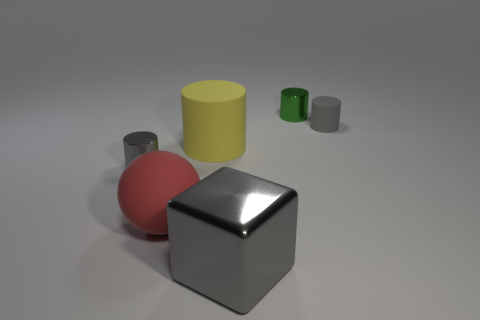Subtract all green cylinders. How many cylinders are left? 3 Subtract all gray cylinders. How many cylinders are left? 2 Subtract all blocks. How many objects are left? 5 Subtract 1 cylinders. How many cylinders are left? 3 Subtract all purple balls. Subtract all gray cubes. How many balls are left? 1 Subtract all red spheres. How many cyan blocks are left? 0 Subtract all tiny blue metallic cubes. Subtract all gray metal objects. How many objects are left? 4 Add 3 small things. How many small things are left? 6 Add 6 blue shiny blocks. How many blue shiny blocks exist? 6 Add 4 blue metal spheres. How many objects exist? 10 